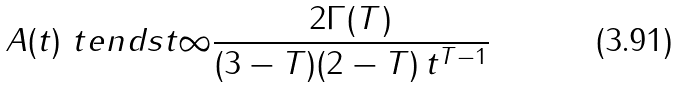Convert formula to latex. <formula><loc_0><loc_0><loc_500><loc_500>A ( t ) \ t e n d s { t } { \infty } \frac { 2 \Gamma ( T ) } { ( 3 - T ) ( 2 - T ) \, t ^ { T - 1 } }</formula> 